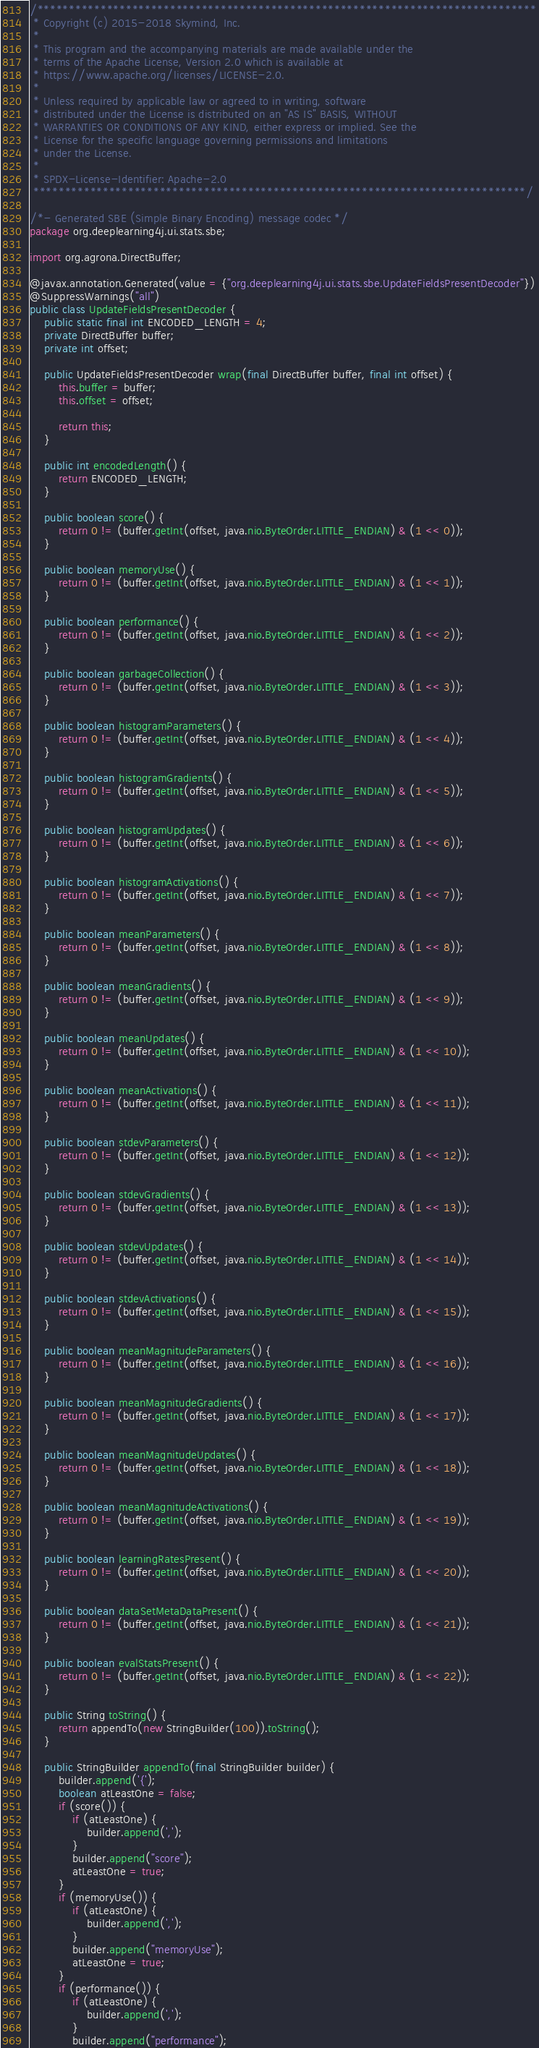<code> <loc_0><loc_0><loc_500><loc_500><_Java_>/*******************************************************************************
 * Copyright (c) 2015-2018 Skymind, Inc.
 *
 * This program and the accompanying materials are made available under the
 * terms of the Apache License, Version 2.0 which is available at
 * https://www.apache.org/licenses/LICENSE-2.0.
 *
 * Unless required by applicable law or agreed to in writing, software
 * distributed under the License is distributed on an "AS IS" BASIS, WITHOUT
 * WARRANTIES OR CONDITIONS OF ANY KIND, either express or implied. See the
 * License for the specific language governing permissions and limitations
 * under the License.
 *
 * SPDX-License-Identifier: Apache-2.0
 ******************************************************************************/

/*- Generated SBE (Simple Binary Encoding) message codec */
package org.deeplearning4j.ui.stats.sbe;

import org.agrona.DirectBuffer;

@javax.annotation.Generated(value = {"org.deeplearning4j.ui.stats.sbe.UpdateFieldsPresentDecoder"})
@SuppressWarnings("all")
public class UpdateFieldsPresentDecoder {
    public static final int ENCODED_LENGTH = 4;
    private DirectBuffer buffer;
    private int offset;

    public UpdateFieldsPresentDecoder wrap(final DirectBuffer buffer, final int offset) {
        this.buffer = buffer;
        this.offset = offset;

        return this;
    }

    public int encodedLength() {
        return ENCODED_LENGTH;
    }

    public boolean score() {
        return 0 != (buffer.getInt(offset, java.nio.ByteOrder.LITTLE_ENDIAN) & (1 << 0));
    }

    public boolean memoryUse() {
        return 0 != (buffer.getInt(offset, java.nio.ByteOrder.LITTLE_ENDIAN) & (1 << 1));
    }

    public boolean performance() {
        return 0 != (buffer.getInt(offset, java.nio.ByteOrder.LITTLE_ENDIAN) & (1 << 2));
    }

    public boolean garbageCollection() {
        return 0 != (buffer.getInt(offset, java.nio.ByteOrder.LITTLE_ENDIAN) & (1 << 3));
    }

    public boolean histogramParameters() {
        return 0 != (buffer.getInt(offset, java.nio.ByteOrder.LITTLE_ENDIAN) & (1 << 4));
    }

    public boolean histogramGradients() {
        return 0 != (buffer.getInt(offset, java.nio.ByteOrder.LITTLE_ENDIAN) & (1 << 5));
    }

    public boolean histogramUpdates() {
        return 0 != (buffer.getInt(offset, java.nio.ByteOrder.LITTLE_ENDIAN) & (1 << 6));
    }

    public boolean histogramActivations() {
        return 0 != (buffer.getInt(offset, java.nio.ByteOrder.LITTLE_ENDIAN) & (1 << 7));
    }

    public boolean meanParameters() {
        return 0 != (buffer.getInt(offset, java.nio.ByteOrder.LITTLE_ENDIAN) & (1 << 8));
    }

    public boolean meanGradients() {
        return 0 != (buffer.getInt(offset, java.nio.ByteOrder.LITTLE_ENDIAN) & (1 << 9));
    }

    public boolean meanUpdates() {
        return 0 != (buffer.getInt(offset, java.nio.ByteOrder.LITTLE_ENDIAN) & (1 << 10));
    }

    public boolean meanActivations() {
        return 0 != (buffer.getInt(offset, java.nio.ByteOrder.LITTLE_ENDIAN) & (1 << 11));
    }

    public boolean stdevParameters() {
        return 0 != (buffer.getInt(offset, java.nio.ByteOrder.LITTLE_ENDIAN) & (1 << 12));
    }

    public boolean stdevGradients() {
        return 0 != (buffer.getInt(offset, java.nio.ByteOrder.LITTLE_ENDIAN) & (1 << 13));
    }

    public boolean stdevUpdates() {
        return 0 != (buffer.getInt(offset, java.nio.ByteOrder.LITTLE_ENDIAN) & (1 << 14));
    }

    public boolean stdevActivations() {
        return 0 != (buffer.getInt(offset, java.nio.ByteOrder.LITTLE_ENDIAN) & (1 << 15));
    }

    public boolean meanMagnitudeParameters() {
        return 0 != (buffer.getInt(offset, java.nio.ByteOrder.LITTLE_ENDIAN) & (1 << 16));
    }

    public boolean meanMagnitudeGradients() {
        return 0 != (buffer.getInt(offset, java.nio.ByteOrder.LITTLE_ENDIAN) & (1 << 17));
    }

    public boolean meanMagnitudeUpdates() {
        return 0 != (buffer.getInt(offset, java.nio.ByteOrder.LITTLE_ENDIAN) & (1 << 18));
    }

    public boolean meanMagnitudeActivations() {
        return 0 != (buffer.getInt(offset, java.nio.ByteOrder.LITTLE_ENDIAN) & (1 << 19));
    }

    public boolean learningRatesPresent() {
        return 0 != (buffer.getInt(offset, java.nio.ByteOrder.LITTLE_ENDIAN) & (1 << 20));
    }

    public boolean dataSetMetaDataPresent() {
        return 0 != (buffer.getInt(offset, java.nio.ByteOrder.LITTLE_ENDIAN) & (1 << 21));
    }

    public boolean evalStatsPresent() {
        return 0 != (buffer.getInt(offset, java.nio.ByteOrder.LITTLE_ENDIAN) & (1 << 22));
    }

    public String toString() {
        return appendTo(new StringBuilder(100)).toString();
    }

    public StringBuilder appendTo(final StringBuilder builder) {
        builder.append('{');
        boolean atLeastOne = false;
        if (score()) {
            if (atLeastOne) {
                builder.append(',');
            }
            builder.append("score");
            atLeastOne = true;
        }
        if (memoryUse()) {
            if (atLeastOne) {
                builder.append(',');
            }
            builder.append("memoryUse");
            atLeastOne = true;
        }
        if (performance()) {
            if (atLeastOne) {
                builder.append(',');
            }
            builder.append("performance");</code> 